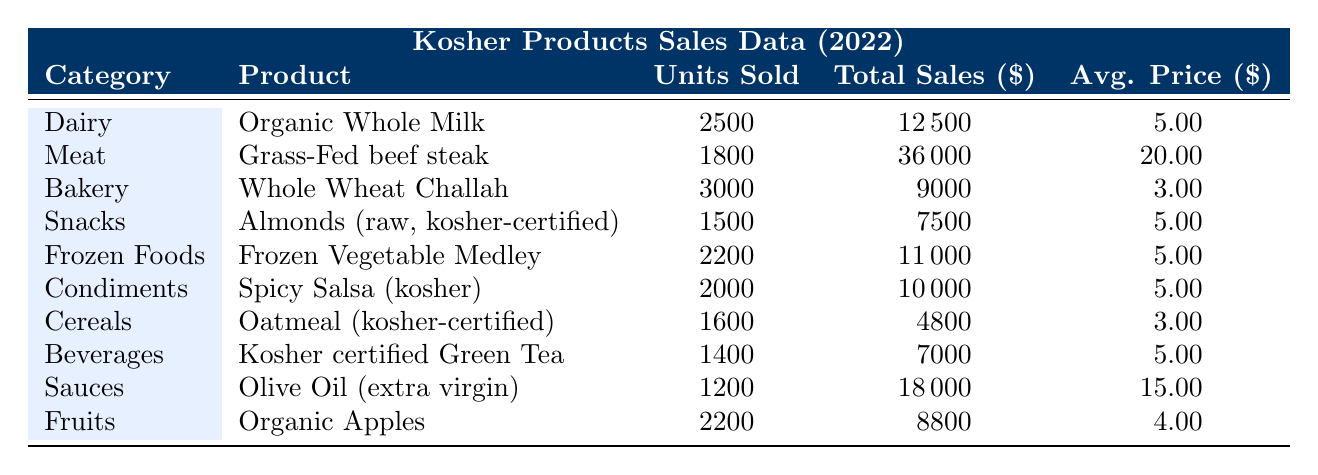What is the total sales for the Organic Whole Milk? The total sales for Organic Whole Milk is listed directly in the table under the Total Sales column, which shows $12,500.
Answer: $12,500 How many units of Grass-Fed beef steak were sold? The units sold for Grass-Fed beef steak can be found in the Units Sold column of the table, where it indicates 1,800 units.
Answer: 1,800 Which product category had the highest total sales, and what was the amount? By reviewing the Total Sales column, we see that the Meat category had the highest total sales of $36,000 for Grass-Fed beef steak.
Answer: Meat, $36,000 What is the average price per unit for Whole Wheat Challah? The average price per unit for Whole Wheat Challah is noted in the Avg. Price column, which shows $3.00.
Answer: $3.00 What is the total sales for all products under the Snacks category? In the table, the total sales for the Snacks category, specifically for Almonds (raw, kosher-certified), is $7,500.
Answer: $7,500 Is the average price per unit for Frozen Vegetable Medley greater than $4? The average price per unit for Frozen Vegetable Medley is listed as $5.00 in the Avg. Price column, which is greater than $4. Thus, the answer is yes.
Answer: Yes Which product has the lowest average price per unit, and what is that price? By comparing the Avg. Price column, it is evident that Whole Wheat Challah ($3.00) and Oatmeal (kosher-certified) ($3.00) are the lowest priced products.
Answer: Whole Wheat Challah, $3.00 What is the total number of units sold across all Dairy products? The only Dairy product listed is Organic Whole Milk which sold 2,500 units. Therefore, the total number of units sold across all Dairy products is 2,500.
Answer: 2,500 What is the difference in total sales between the highest-selling product and the lowest-selling product? The highest-selling product is Grass-Fed beef steak with total sales of $36,000, while the lowest is Oatmeal (kosher-certified) with total sales of $4,800. The difference is $36,000 - $4,800 = $31,200.
Answer: $31,200 